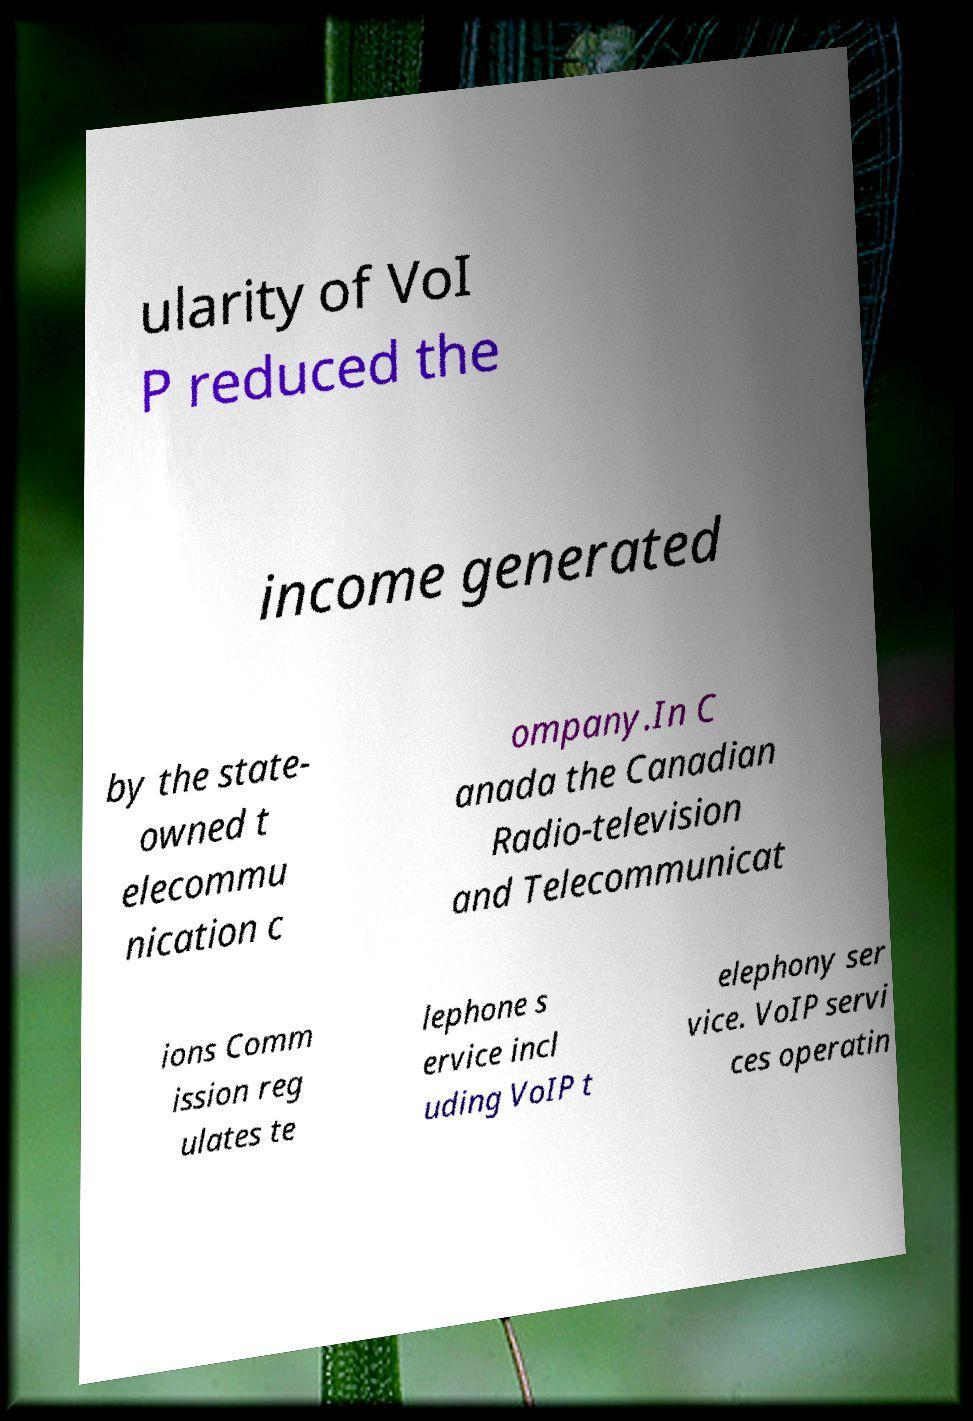I need the written content from this picture converted into text. Can you do that? ularity of VoI P reduced the income generated by the state- owned t elecommu nication c ompany.In C anada the Canadian Radio-television and Telecommunicat ions Comm ission reg ulates te lephone s ervice incl uding VoIP t elephony ser vice. VoIP servi ces operatin 